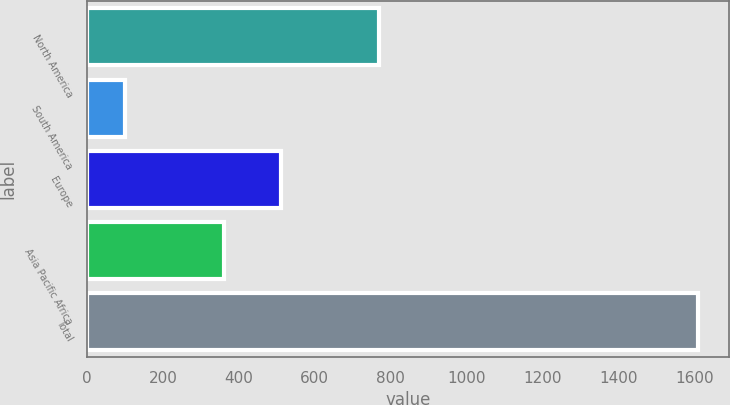<chart> <loc_0><loc_0><loc_500><loc_500><bar_chart><fcel>North America<fcel>South America<fcel>Europe<fcel>Asia Pacific Africa<fcel>Total<nl><fcel>770<fcel>100<fcel>511<fcel>360<fcel>1610<nl></chart> 